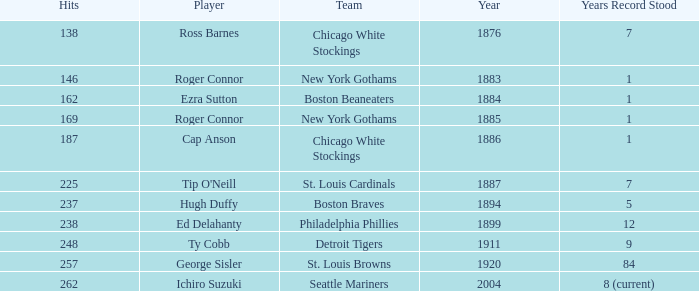Name the hits for years before 1883 138.0. 